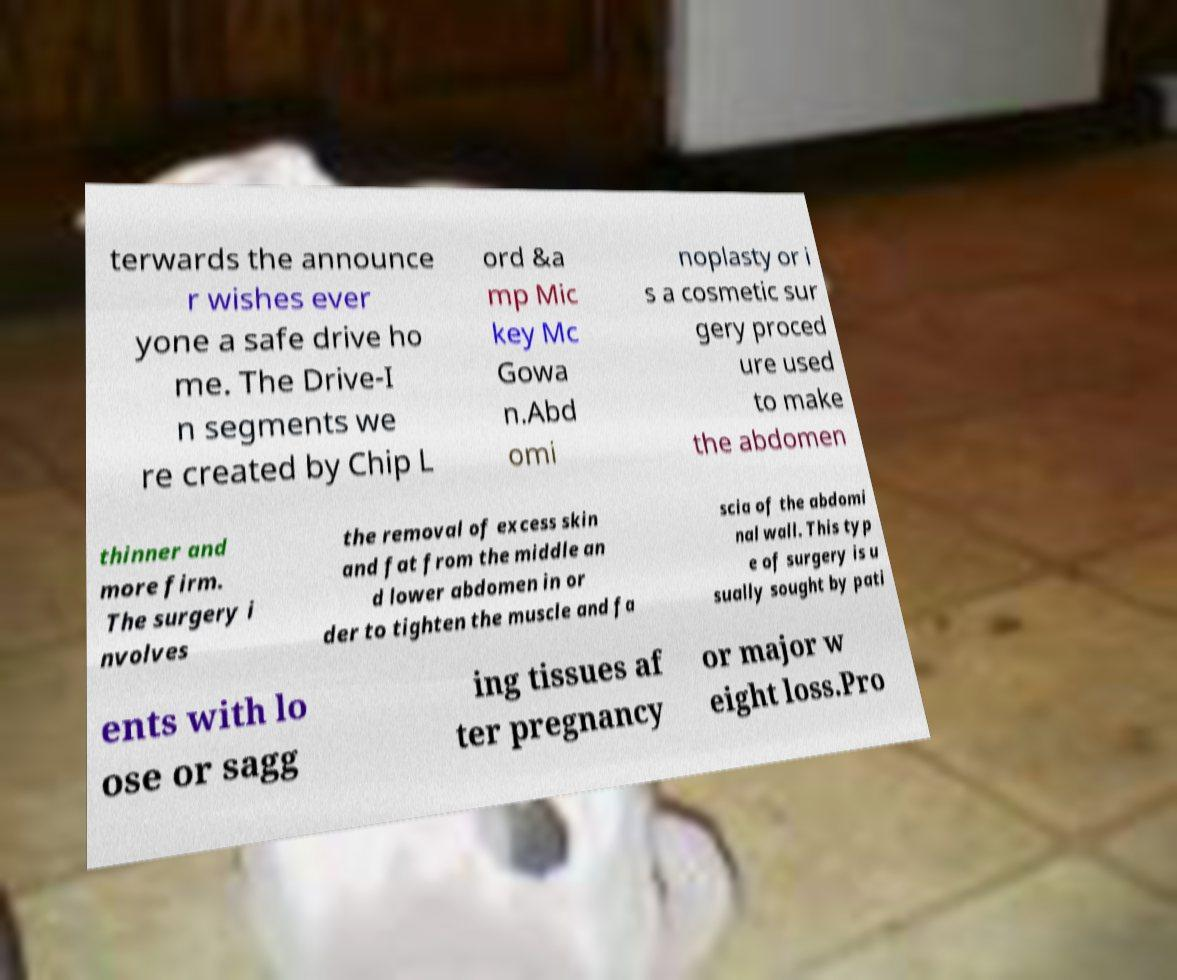Can you read and provide the text displayed in the image?This photo seems to have some interesting text. Can you extract and type it out for me? terwards the announce r wishes ever yone a safe drive ho me. The Drive-I n segments we re created by Chip L ord &a mp Mic key Mc Gowa n.Abd omi noplasty or i s a cosmetic sur gery proced ure used to make the abdomen thinner and more firm. The surgery i nvolves the removal of excess skin and fat from the middle an d lower abdomen in or der to tighten the muscle and fa scia of the abdomi nal wall. This typ e of surgery is u sually sought by pati ents with lo ose or sagg ing tissues af ter pregnancy or major w eight loss.Pro 